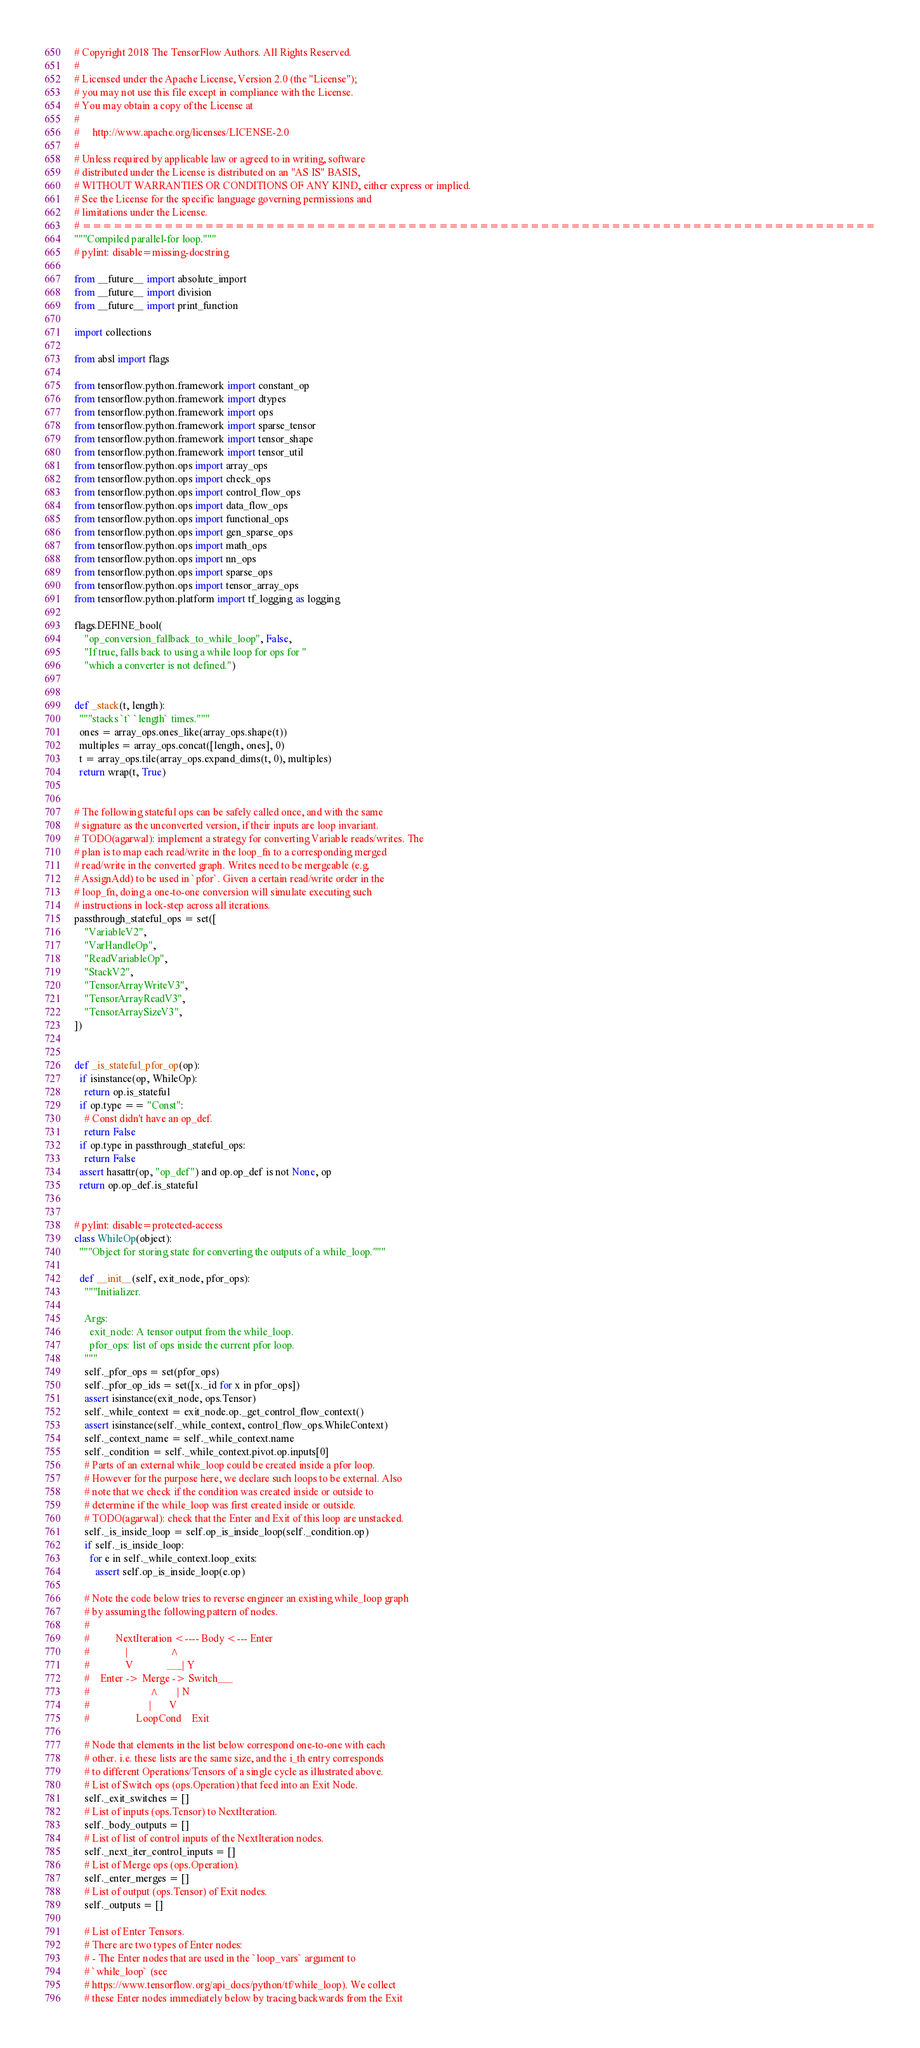<code> <loc_0><loc_0><loc_500><loc_500><_Python_># Copyright 2018 The TensorFlow Authors. All Rights Reserved.
#
# Licensed under the Apache License, Version 2.0 (the "License");
# you may not use this file except in compliance with the License.
# You may obtain a copy of the License at
#
#     http://www.apache.org/licenses/LICENSE-2.0
#
# Unless required by applicable law or agreed to in writing, software
# distributed under the License is distributed on an "AS IS" BASIS,
# WITHOUT WARRANTIES OR CONDITIONS OF ANY KIND, either express or implied.
# See the License for the specific language governing permissions and
# limitations under the License.
# ==============================================================================
"""Compiled parallel-for loop."""
# pylint: disable=missing-docstring

from __future__ import absolute_import
from __future__ import division
from __future__ import print_function

import collections

from absl import flags

from tensorflow.python.framework import constant_op
from tensorflow.python.framework import dtypes
from tensorflow.python.framework import ops
from tensorflow.python.framework import sparse_tensor
from tensorflow.python.framework import tensor_shape
from tensorflow.python.framework import tensor_util
from tensorflow.python.ops import array_ops
from tensorflow.python.ops import check_ops
from tensorflow.python.ops import control_flow_ops
from tensorflow.python.ops import data_flow_ops
from tensorflow.python.ops import functional_ops
from tensorflow.python.ops import gen_sparse_ops
from tensorflow.python.ops import math_ops
from tensorflow.python.ops import nn_ops
from tensorflow.python.ops import sparse_ops
from tensorflow.python.ops import tensor_array_ops
from tensorflow.python.platform import tf_logging as logging

flags.DEFINE_bool(
    "op_conversion_fallback_to_while_loop", False,
    "If true, falls back to using a while loop for ops for "
    "which a converter is not defined.")


def _stack(t, length):
  """stacks `t` `length` times."""
  ones = array_ops.ones_like(array_ops.shape(t))
  multiples = array_ops.concat([length, ones], 0)
  t = array_ops.tile(array_ops.expand_dims(t, 0), multiples)
  return wrap(t, True)


# The following stateful ops can be safely called once, and with the same
# signature as the unconverted version, if their inputs are loop invariant.
# TODO(agarwal): implement a strategy for converting Variable reads/writes. The
# plan is to map each read/write in the loop_fn to a corresponding merged
# read/write in the converted graph. Writes need to be mergeable (e.g.
# AssignAdd) to be used in `pfor`. Given a certain read/write order in the
# loop_fn, doing a one-to-one conversion will simulate executing such
# instructions in lock-step across all iterations.
passthrough_stateful_ops = set([
    "VariableV2",
    "VarHandleOp",
    "ReadVariableOp",
    "StackV2",
    "TensorArrayWriteV3",
    "TensorArrayReadV3",
    "TensorArraySizeV3",
])


def _is_stateful_pfor_op(op):
  if isinstance(op, WhileOp):
    return op.is_stateful
  if op.type == "Const":
    # Const didn't have an op_def.
    return False
  if op.type in passthrough_stateful_ops:
    return False
  assert hasattr(op, "op_def") and op.op_def is not None, op
  return op.op_def.is_stateful


# pylint: disable=protected-access
class WhileOp(object):
  """Object for storing state for converting the outputs of a while_loop."""

  def __init__(self, exit_node, pfor_ops):
    """Initializer.

    Args:
      exit_node: A tensor output from the while_loop.
      pfor_ops: list of ops inside the current pfor loop.
    """
    self._pfor_ops = set(pfor_ops)
    self._pfor_op_ids = set([x._id for x in pfor_ops])
    assert isinstance(exit_node, ops.Tensor)
    self._while_context = exit_node.op._get_control_flow_context()
    assert isinstance(self._while_context, control_flow_ops.WhileContext)
    self._context_name = self._while_context.name
    self._condition = self._while_context.pivot.op.inputs[0]
    # Parts of an external while_loop could be created inside a pfor loop.
    # However for the purpose here, we declare such loops to be external. Also
    # note that we check if the condition was created inside or outside to
    # determine if the while_loop was first created inside or outside.
    # TODO(agarwal): check that the Enter and Exit of this loop are unstacked.
    self._is_inside_loop = self.op_is_inside_loop(self._condition.op)
    if self._is_inside_loop:
      for e in self._while_context.loop_exits:
        assert self.op_is_inside_loop(e.op)

    # Note the code below tries to reverse engineer an existing while_loop graph
    # by assuming the following pattern of nodes.
    #
    #          NextIteration <---- Body <--- Enter
    #              |                ^
    #              V             ___| Y
    #    Enter -> Merge -> Switch___
    #                       ^       | N
    #                       |       V
    #                  LoopCond    Exit

    # Node that elements in the list below correspond one-to-one with each
    # other. i.e. these lists are the same size, and the i_th entry corresponds
    # to different Operations/Tensors of a single cycle as illustrated above.
    # List of Switch ops (ops.Operation) that feed into an Exit Node.
    self._exit_switches = []
    # List of inputs (ops.Tensor) to NextIteration.
    self._body_outputs = []
    # List of list of control inputs of the NextIteration nodes.
    self._next_iter_control_inputs = []
    # List of Merge ops (ops.Operation).
    self._enter_merges = []
    # List of output (ops.Tensor) of Exit nodes.
    self._outputs = []

    # List of Enter Tensors.
    # There are two types of Enter nodes:
    # - The Enter nodes that are used in the `loop_vars` argument to
    # `while_loop` (see
    # https://www.tensorflow.org/api_docs/python/tf/while_loop). We collect
    # these Enter nodes immediately below by tracing backwards from the Exit</code> 